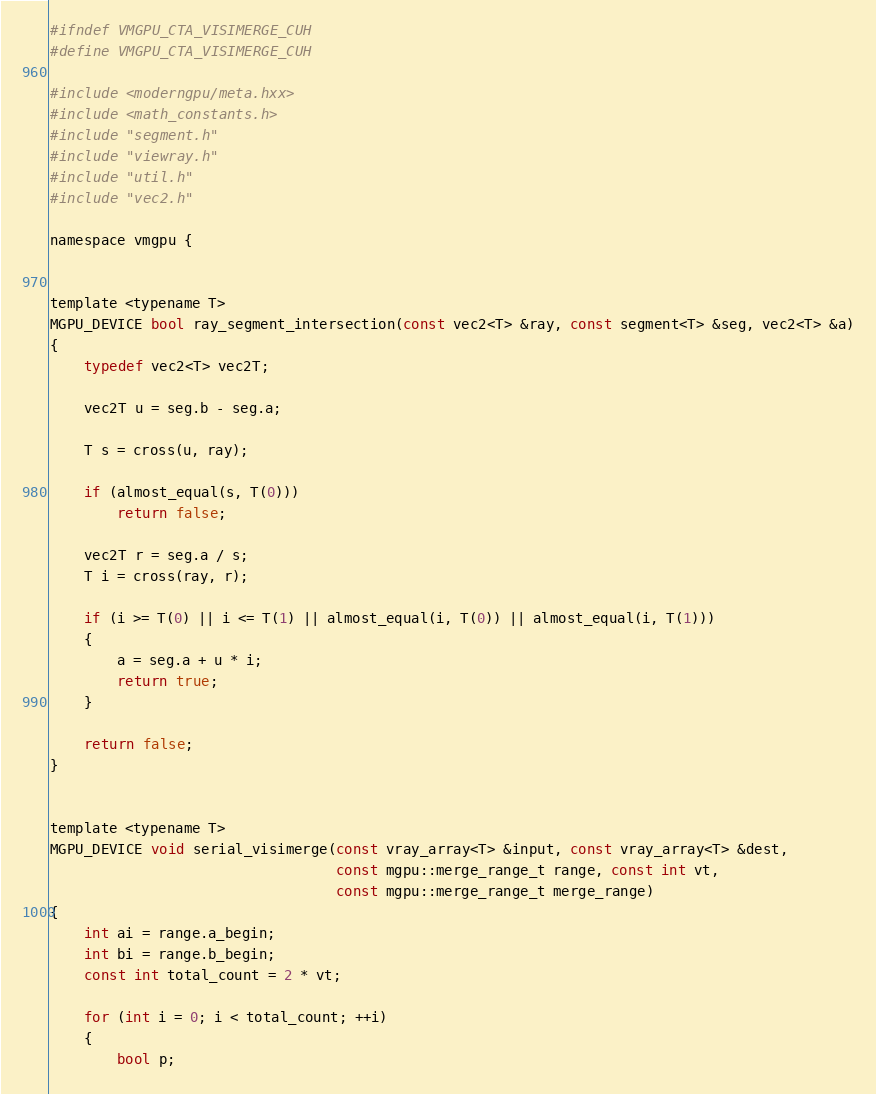<code> <loc_0><loc_0><loc_500><loc_500><_Cuda_>#ifndef VMGPU_CTA_VISIMERGE_CUH
#define VMGPU_CTA_VISIMERGE_CUH

#include <moderngpu/meta.hxx>
#include <math_constants.h>
#include "segment.h"
#include "viewray.h"
#include "util.h"
#include "vec2.h"

namespace vmgpu {


template <typename T>
MGPU_DEVICE bool ray_segment_intersection(const vec2<T> &ray, const segment<T> &seg, vec2<T> &a)
{
    typedef vec2<T> vec2T;

    vec2T u = seg.b - seg.a;

    T s = cross(u, ray);

    if (almost_equal(s, T(0)))
        return false;

    vec2T r = seg.a / s;
    T i = cross(ray, r);

    if (i >= T(0) || i <= T(1) || almost_equal(i, T(0)) || almost_equal(i, T(1)))
    {
        a = seg.a + u * i;
        return true;
    }

    return false;
}


template <typename T>
MGPU_DEVICE void serial_visimerge(const vray_array<T> &input, const vray_array<T> &dest,
                                  const mgpu::merge_range_t range, const int vt,
                                  const mgpu::merge_range_t merge_range)
{
    int ai = range.a_begin;
    int bi = range.b_begin;
    const int total_count = 2 * vt;

    for (int i = 0; i < total_count; ++i)
    {
        bool p;</code> 